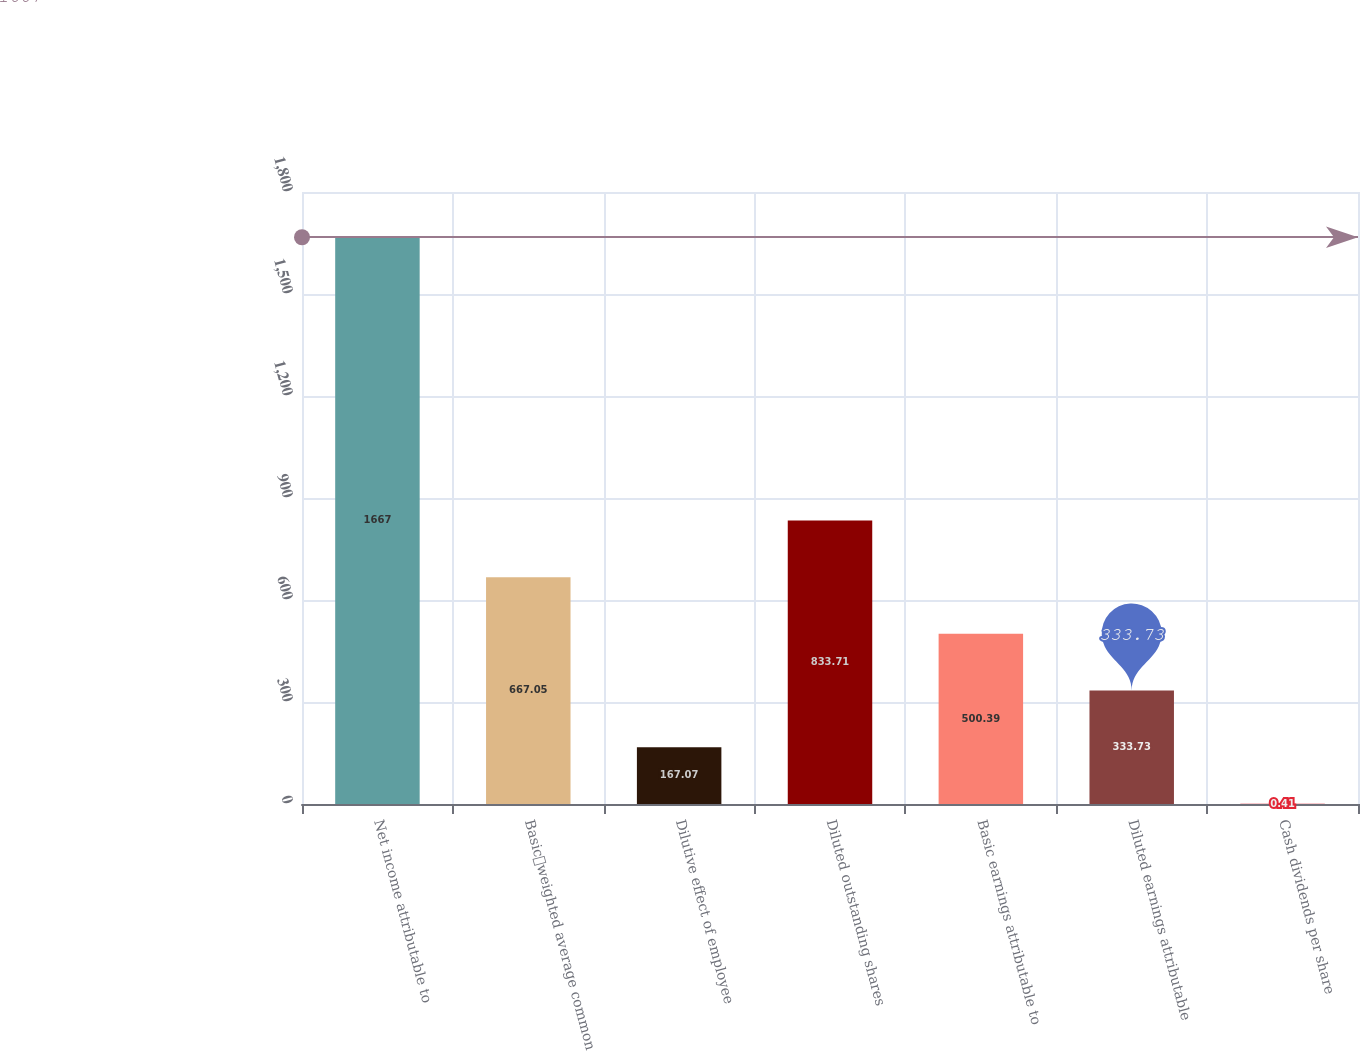Convert chart. <chart><loc_0><loc_0><loc_500><loc_500><bar_chart><fcel>Net income attributable to<fcel>Basicweighted average common<fcel>Dilutive effect of employee<fcel>Diluted outstanding shares<fcel>Basic earnings attributable to<fcel>Diluted earnings attributable<fcel>Cash dividends per share<nl><fcel>1667<fcel>667.05<fcel>167.07<fcel>833.71<fcel>500.39<fcel>333.73<fcel>0.41<nl></chart> 